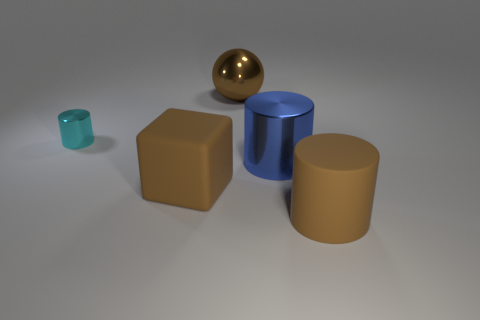Is the color of the cylinder that is in front of the blue thing the same as the big metal ball that is behind the block?
Your answer should be very brief. Yes. How many other objects are the same color as the large ball?
Keep it short and to the point. 2. There is a brown object behind the tiny metal cylinder; what shape is it?
Offer a terse response. Sphere. Is the number of large spheres less than the number of things?
Keep it short and to the point. Yes. Is the large thing right of the blue cylinder made of the same material as the large sphere?
Offer a terse response. No. Are there any other things that are the same size as the cyan cylinder?
Offer a terse response. No. Are there any small cyan shiny things in front of the large blue object?
Provide a succinct answer. No. What color is the thing that is on the left side of the matte object that is left of the large brown object that is behind the tiny cyan metal thing?
Make the answer very short. Cyan. There is a blue metal object that is the same size as the ball; what shape is it?
Keep it short and to the point. Cylinder. Are there more small metal things than tiny blue blocks?
Your answer should be compact. Yes. 